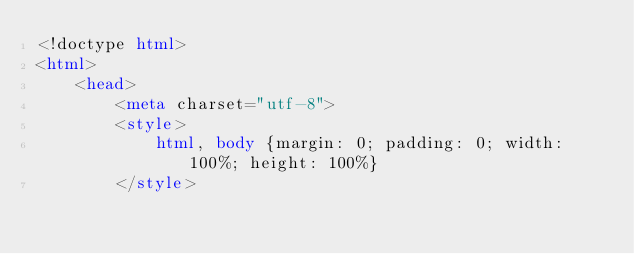Convert code to text. <code><loc_0><loc_0><loc_500><loc_500><_HTML_><!doctype html>
<html>
	<head>
		<meta charset="utf-8">
		<style>
			html, body {margin: 0; padding: 0; width: 100%; height: 100%}
		</style></code> 